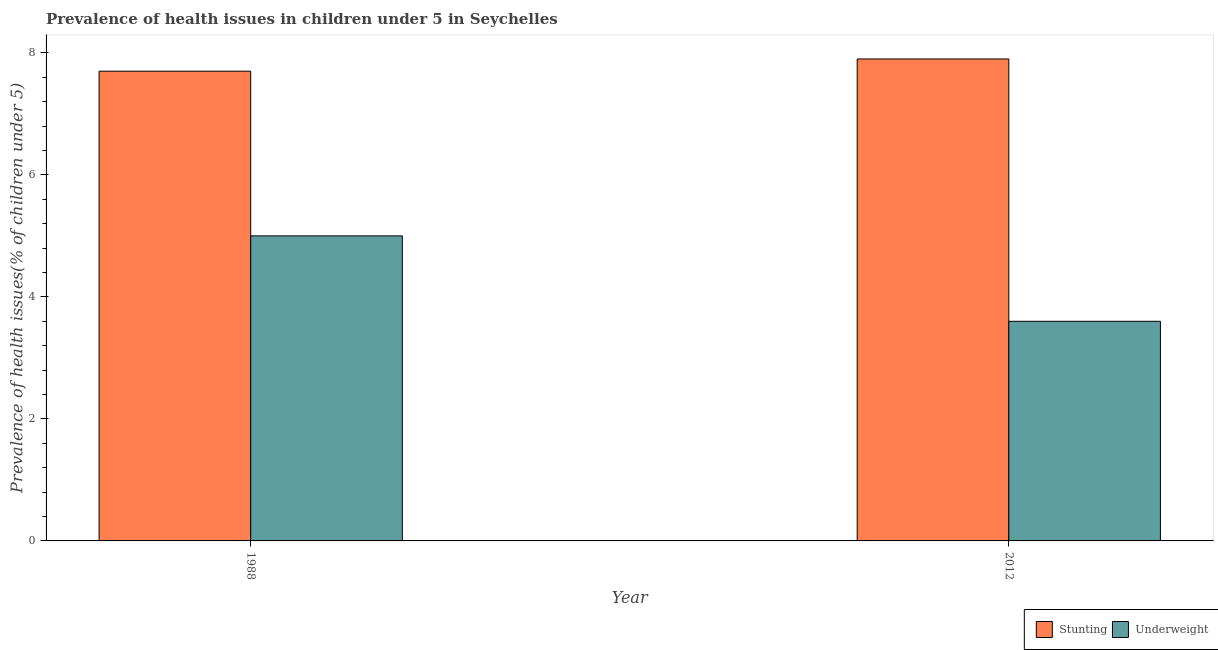Are the number of bars per tick equal to the number of legend labels?
Make the answer very short. Yes. Are the number of bars on each tick of the X-axis equal?
Ensure brevity in your answer.  Yes. How many bars are there on the 2nd tick from the right?
Ensure brevity in your answer.  2. In how many cases, is the number of bars for a given year not equal to the number of legend labels?
Make the answer very short. 0. What is the percentage of underweight children in 1988?
Make the answer very short. 5. Across all years, what is the minimum percentage of stunted children?
Your answer should be compact. 7.7. What is the total percentage of stunted children in the graph?
Your answer should be compact. 15.6. What is the difference between the percentage of underweight children in 1988 and that in 2012?
Keep it short and to the point. 1.4. What is the difference between the percentage of stunted children in 1988 and the percentage of underweight children in 2012?
Provide a succinct answer. -0.2. What is the average percentage of stunted children per year?
Ensure brevity in your answer.  7.8. In the year 1988, what is the difference between the percentage of stunted children and percentage of underweight children?
Your answer should be very brief. 0. In how many years, is the percentage of stunted children greater than 6.8 %?
Keep it short and to the point. 2. What is the ratio of the percentage of underweight children in 1988 to that in 2012?
Your answer should be very brief. 1.39. What does the 2nd bar from the left in 2012 represents?
Provide a short and direct response. Underweight. What does the 2nd bar from the right in 1988 represents?
Keep it short and to the point. Stunting. How many bars are there?
Give a very brief answer. 4. Are the values on the major ticks of Y-axis written in scientific E-notation?
Your answer should be compact. No. Does the graph contain any zero values?
Ensure brevity in your answer.  No. Does the graph contain grids?
Your answer should be very brief. No. Where does the legend appear in the graph?
Provide a succinct answer. Bottom right. How many legend labels are there?
Provide a short and direct response. 2. What is the title of the graph?
Offer a very short reply. Prevalence of health issues in children under 5 in Seychelles. Does "Banks" appear as one of the legend labels in the graph?
Ensure brevity in your answer.  No. What is the label or title of the Y-axis?
Keep it short and to the point. Prevalence of health issues(% of children under 5). What is the Prevalence of health issues(% of children under 5) of Stunting in 1988?
Ensure brevity in your answer.  7.7. What is the Prevalence of health issues(% of children under 5) of Stunting in 2012?
Provide a succinct answer. 7.9. What is the Prevalence of health issues(% of children under 5) of Underweight in 2012?
Ensure brevity in your answer.  3.6. Across all years, what is the maximum Prevalence of health issues(% of children under 5) of Stunting?
Keep it short and to the point. 7.9. Across all years, what is the minimum Prevalence of health issues(% of children under 5) in Stunting?
Offer a terse response. 7.7. Across all years, what is the minimum Prevalence of health issues(% of children under 5) of Underweight?
Keep it short and to the point. 3.6. What is the total Prevalence of health issues(% of children under 5) of Stunting in the graph?
Provide a short and direct response. 15.6. What is the total Prevalence of health issues(% of children under 5) of Underweight in the graph?
Keep it short and to the point. 8.6. What is the difference between the Prevalence of health issues(% of children under 5) of Stunting in 1988 and that in 2012?
Ensure brevity in your answer.  -0.2. What is the difference between the Prevalence of health issues(% of children under 5) of Underweight in 1988 and that in 2012?
Make the answer very short. 1.4. What is the difference between the Prevalence of health issues(% of children under 5) of Stunting in 1988 and the Prevalence of health issues(% of children under 5) of Underweight in 2012?
Ensure brevity in your answer.  4.1. In the year 1988, what is the difference between the Prevalence of health issues(% of children under 5) of Stunting and Prevalence of health issues(% of children under 5) of Underweight?
Your answer should be compact. 2.7. What is the ratio of the Prevalence of health issues(% of children under 5) in Stunting in 1988 to that in 2012?
Offer a terse response. 0.97. What is the ratio of the Prevalence of health issues(% of children under 5) of Underweight in 1988 to that in 2012?
Give a very brief answer. 1.39. What is the difference between the highest and the lowest Prevalence of health issues(% of children under 5) in Underweight?
Ensure brevity in your answer.  1.4. 